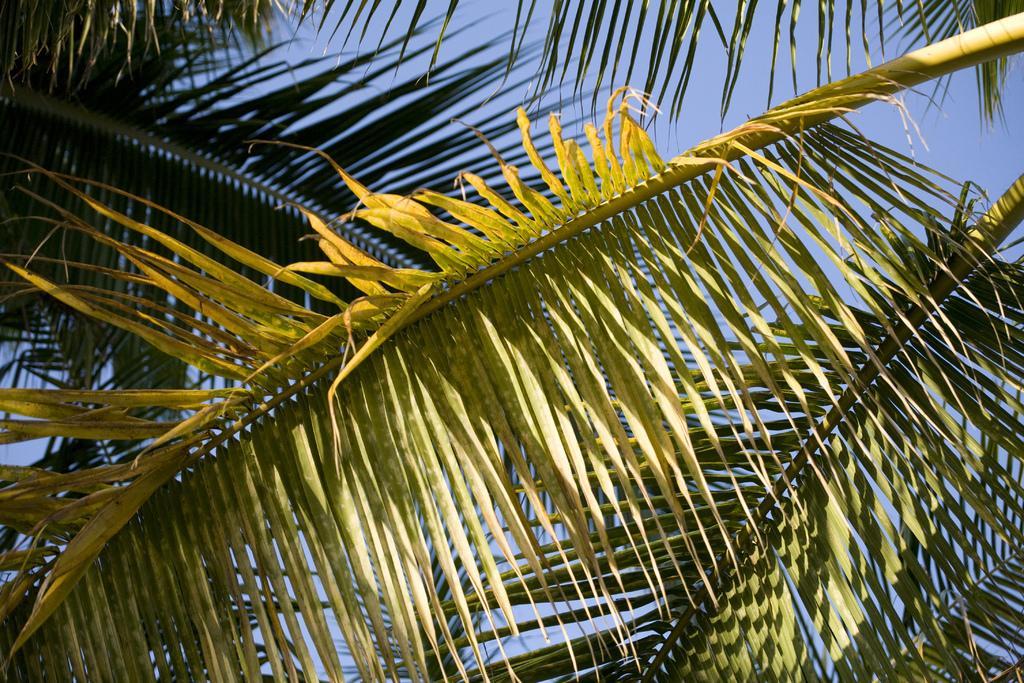In one or two sentences, can you explain what this image depicts? In this picture in the front there are leaves. 